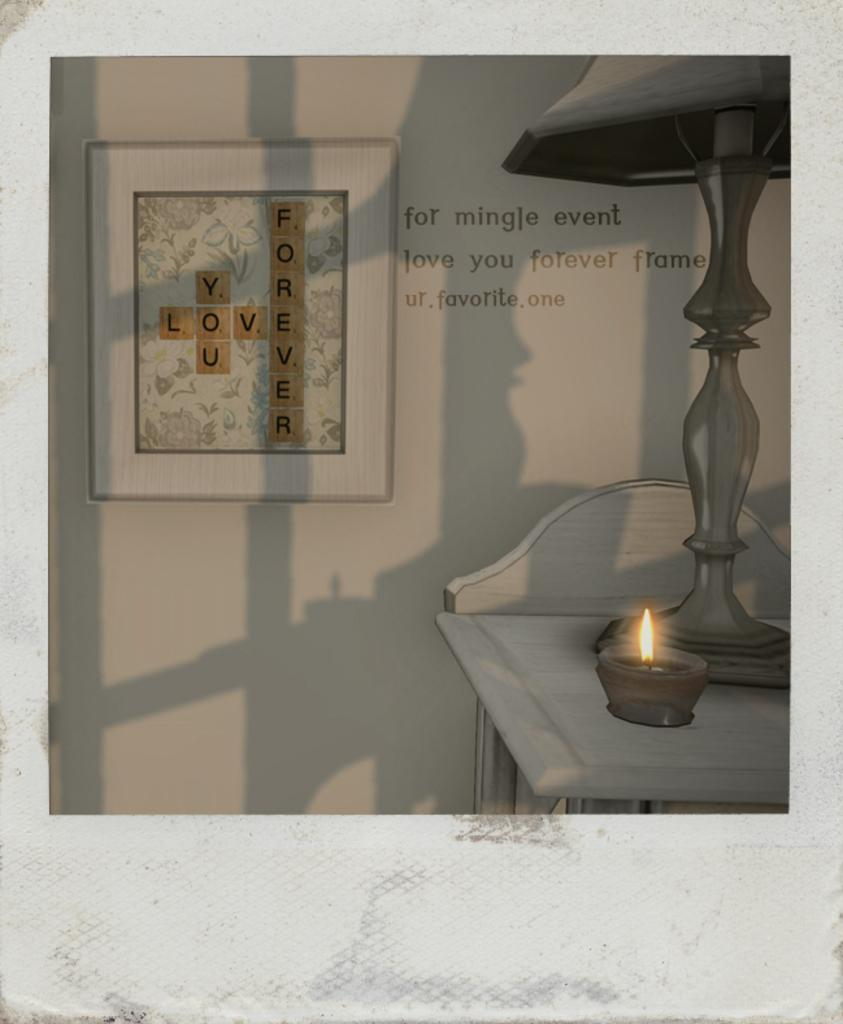What is hanging on the wall in the image? There is a photo frame on the wall in the image. What can be seen written on the wall in the image? There is text on the wall in the image. What type of furniture is present in the image? There is a table in the image, and a lamp is on it. How many servants are visible in the image? There are no servants present in the image. What season is depicted in the image? The image does not depict a specific season, such as winter. 